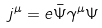<formula> <loc_0><loc_0><loc_500><loc_500>j ^ { \mu } = e \bar { \Psi } \gamma ^ { \mu } \Psi</formula> 